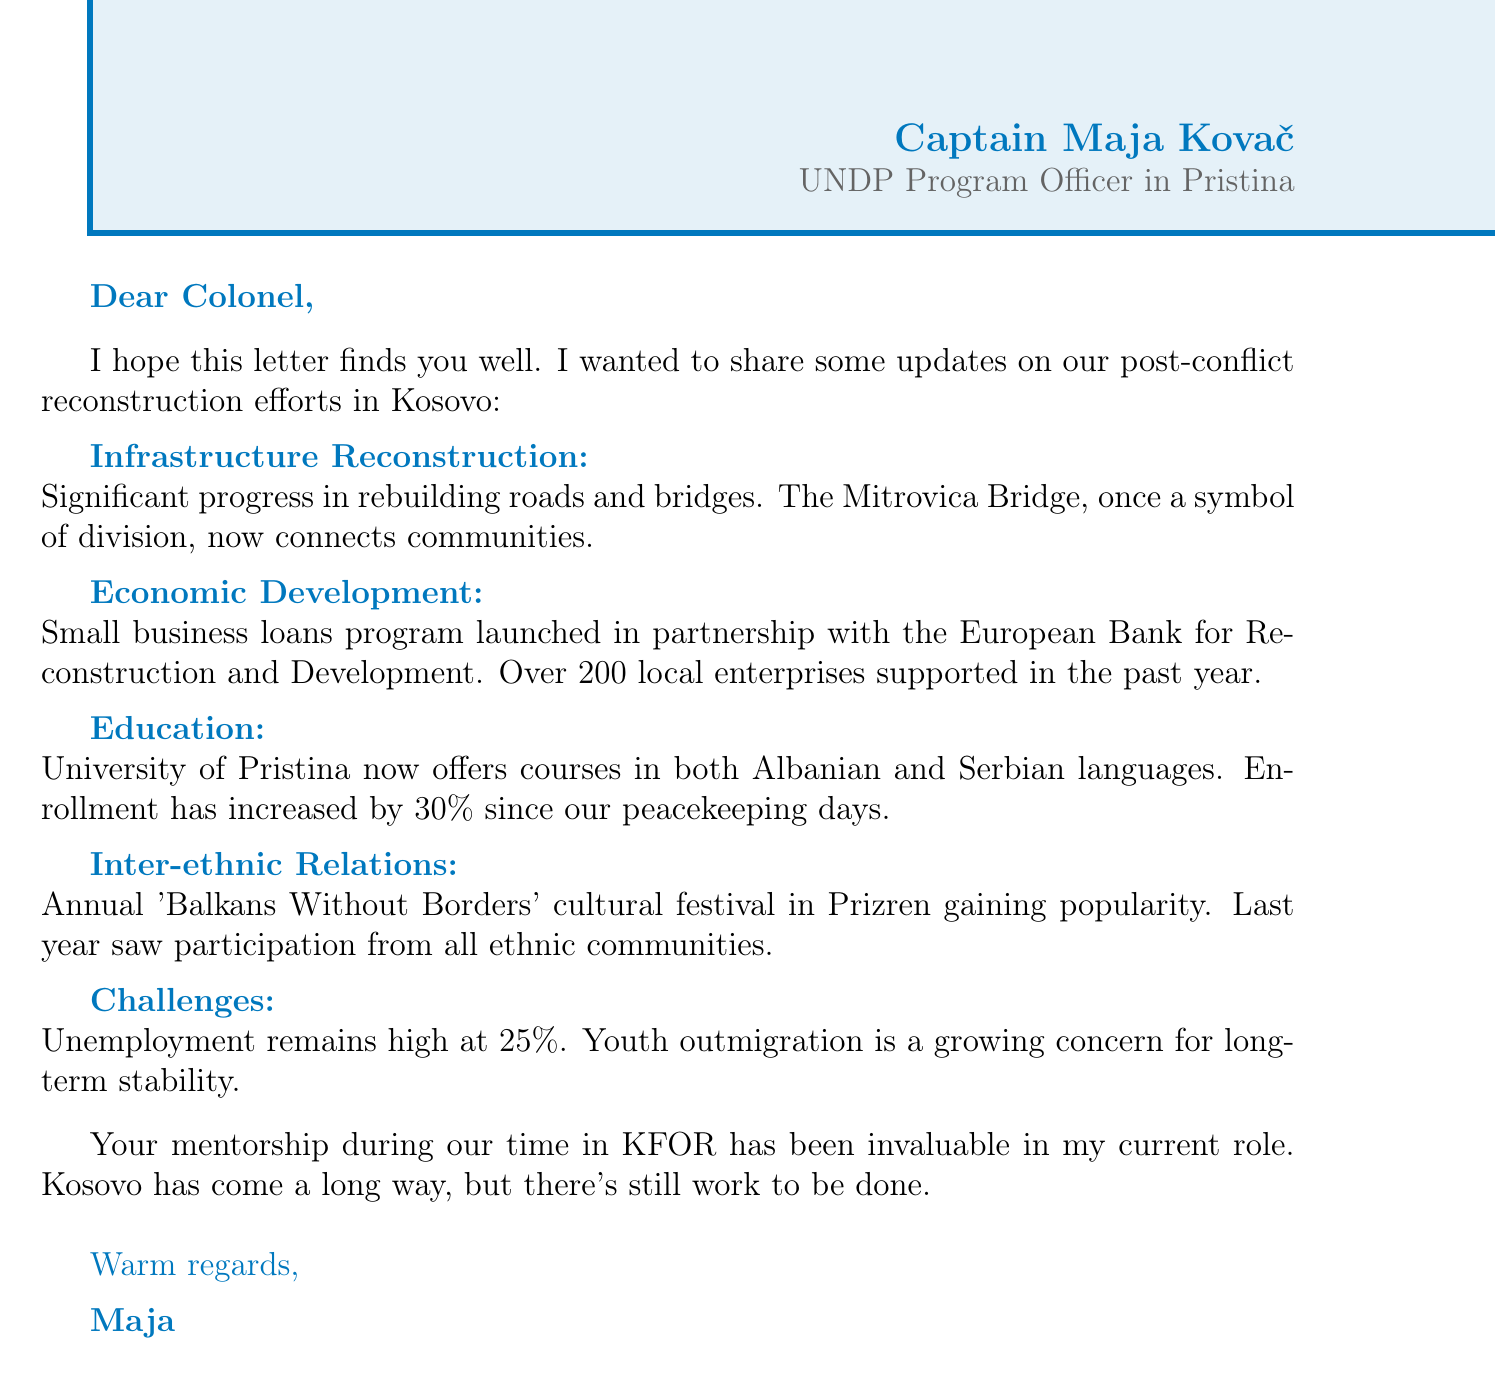What is Captain Maja Kovač's current role? The document states that Captain Maja Kovač is an UNDP Program Officer in Pristina.
Answer: UNDP Program Officer in Pristina What has been rebuilt in Kosovo according to the letter? The letter mentions significant progress in rebuilding roads and bridges, particularly the Mitrovica Bridge.
Answer: Roads and bridges How many local enterprises were supported in the past year? The document specifies that over 200 local enterprises were supported through the small business loans program.
Answer: Over 200 What percentage did university enrollment increase by? The document indicates that enrollment at the University of Pristina increased by 30% since the peacekeeping days.
Answer: 30% What is the current unemployment rate mentioned? The letter states that unemployment remains high at 25%.
Answer: 25% What annual event is mentioned that involves all ethnic communities? The letter references the 'Balkans Without Borders' cultural festival in Prizren.
Answer: 'Balkans Without Borders' cultural festival What concern is raised regarding the youth in Kosovo? The document mentions that youth outmigration is a growing concern for long-term stability.
Answer: Youth outmigration What does Maja Kovač express gratitude for in her personal note? In her personal note, she expresses gratitude for the mentorship she received during their time in KFOR.
Answer: Mentorship during KFOR What is the main focus of the letter? The focus of the letter is on updates regarding post-conflict reconstruction efforts in Kosovo.
Answer: Post-conflict reconstruction efforts in Kosovo 